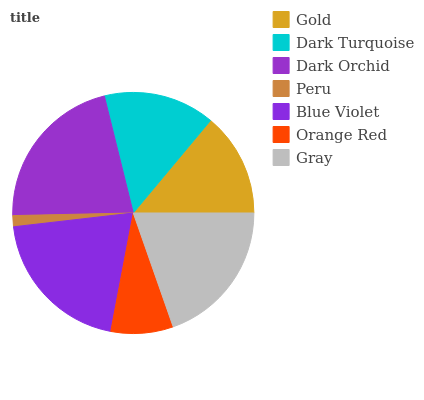Is Peru the minimum?
Answer yes or no. Yes. Is Dark Orchid the maximum?
Answer yes or no. Yes. Is Dark Turquoise the minimum?
Answer yes or no. No. Is Dark Turquoise the maximum?
Answer yes or no. No. Is Dark Turquoise greater than Gold?
Answer yes or no. Yes. Is Gold less than Dark Turquoise?
Answer yes or no. Yes. Is Gold greater than Dark Turquoise?
Answer yes or no. No. Is Dark Turquoise less than Gold?
Answer yes or no. No. Is Dark Turquoise the high median?
Answer yes or no. Yes. Is Dark Turquoise the low median?
Answer yes or no. Yes. Is Dark Orchid the high median?
Answer yes or no. No. Is Gray the low median?
Answer yes or no. No. 